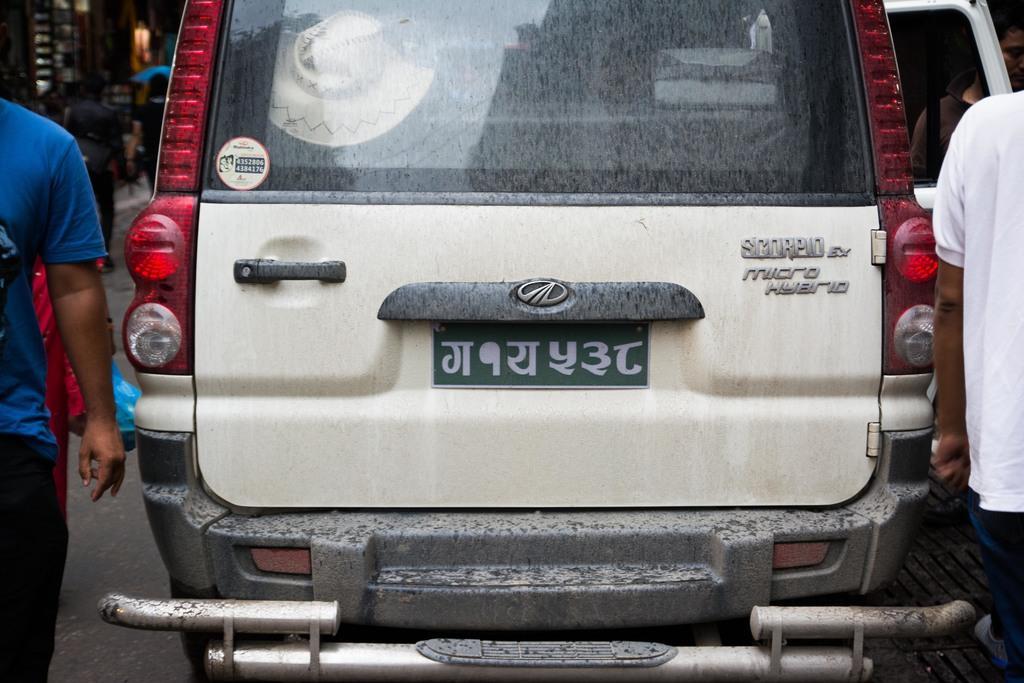Describe this image in one or two sentences. Here I can see a car on the road. On the right and left sides of the image I can see few people are walking. In the background there is a building and few people are walking on the road. 